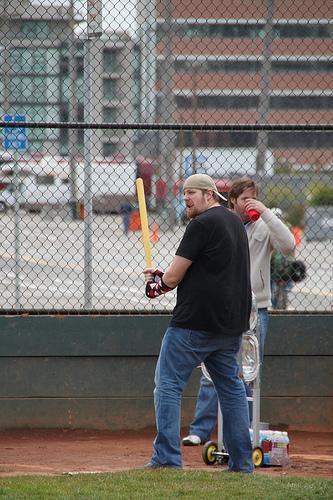How many people are in the picture?
Give a very brief answer. 2. 